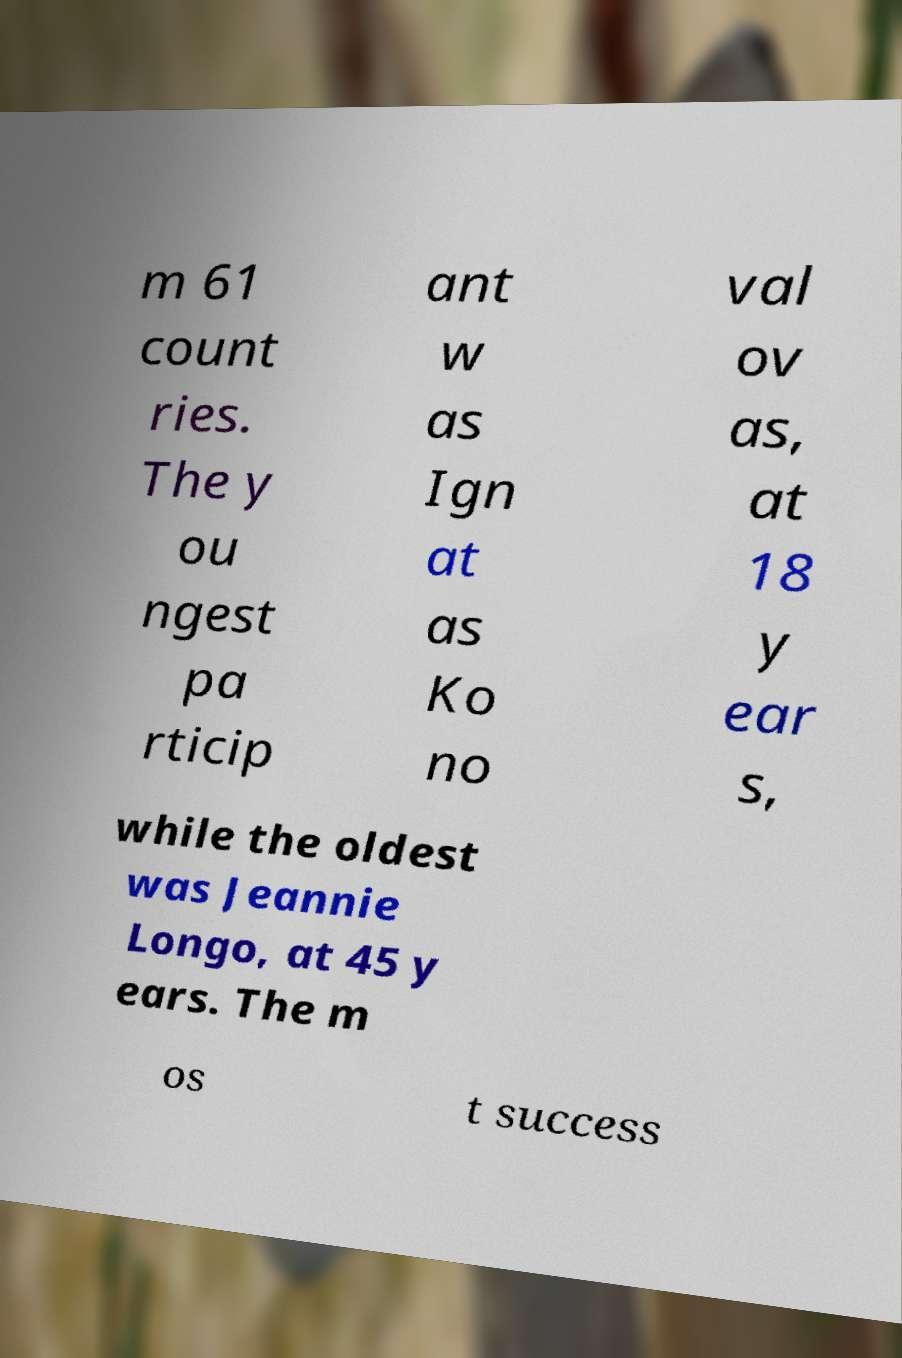Could you assist in decoding the text presented in this image and type it out clearly? m 61 count ries. The y ou ngest pa rticip ant w as Ign at as Ko no val ov as, at 18 y ear s, while the oldest was Jeannie Longo, at 45 y ears. The m os t success 